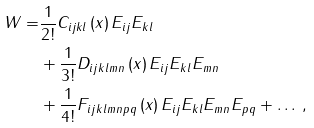<formula> <loc_0><loc_0><loc_500><loc_500>W = & \frac { 1 } { 2 ! } C _ { i j k l } \left ( x \right ) E _ { i j } E _ { k l } \\ & + \frac { 1 } { 3 ! } D _ { i j k l m n } \left ( x \right ) E _ { i j } E _ { k l } E _ { m n } \\ & + \frac { 1 } { 4 ! } F _ { i j k l m n p q } \left ( x \right ) E _ { i j } E _ { k l } E _ { m n } E _ { p q } + \dots \, ,</formula> 